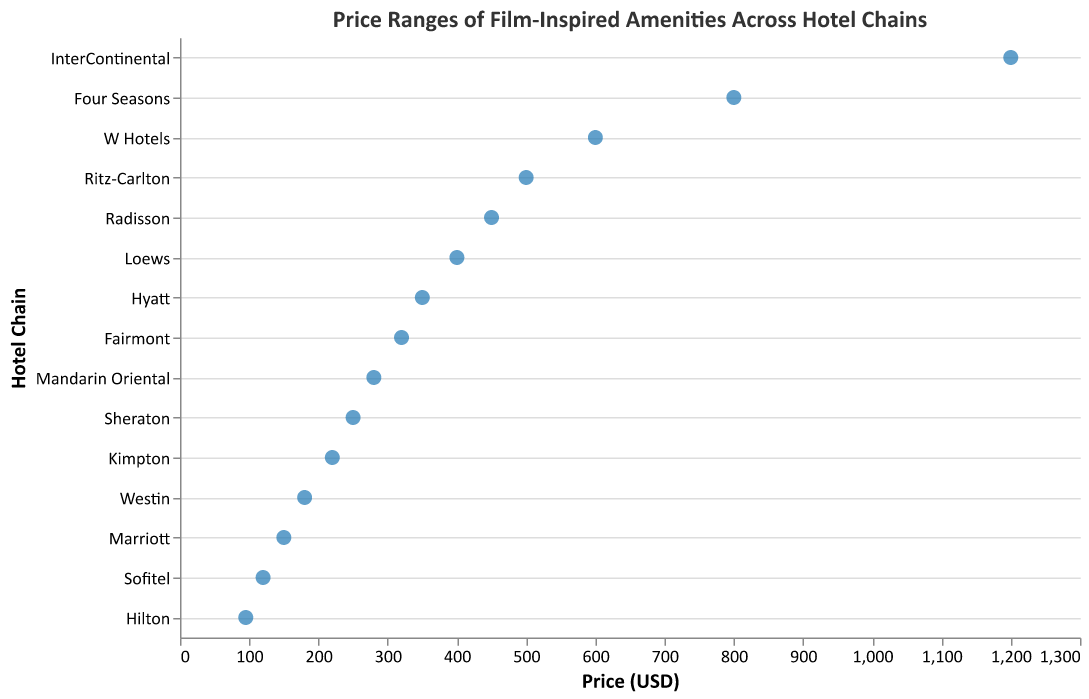How many hotel chains are represented in the plot? The plot shows a data point for each hotel chain. By counting the unique entries on the y-axis, we determine that there are 15 hotel chains represented.
Answer: 15 Which hotel chain features the most expensive film-inspired amenity? The most expensive amenity can be identified by locating the data point furthest to the right on the x-axis. It corresponds to InterContinental's "Game of Thrones Iron Throne Replica" priced at $1200.
Answer: InterContinental What is the price range of the amenities in the plot? The price range can be identified by noting the minimum and maximum x-axis values. The lowest price is for Hilton's "Star Wars Lightsaber Night Light" at $95, and the highest price is InterContinental's "Game of Thrones Iron Throne Replica" at $1200. The range is $1200 - $95 = $1105.
Answer: $1105 Which hotel chain has the lowest priced amenity? The lowest priced amenity can be found by identifying the data point closest to the left on the x-axis, which is Hilton's "Star Wars Lightsaber Night Light" priced at $95.
Answer: Hilton How many amenities are priced below $200? By scanning the x-axis for data points below the $200 mark, we can identify and count the corresponding points: Hilton, Marriott, Sofitel, and Westin provide such amenities. There are 4 in total.
Answer: 4 What is the average price of amenities offered by Ritz-Carlton and Radisson? To find the average price, add the prices of the amenities offered by Ritz-Carlton ($500) and Radisson ($450) and divide by the count of amenities (2). The calculation is ($500 + $450) / 2 = $475.
Answer: $475 Which amenity costs more, the "Jurassic Park Themed Pool" or the "Lord of the Rings Hobbit Hole Suite"? To compare, look at the x-axis values for these amenities. The "Jurassic Park Themed Pool" (Ritz-Carlton) costs $500, and the "Lord of the Rings Hobbit Hole Suite" (Four Seasons) costs $800. The latter costs more.
Answer: Lord of the Rings Hobbit Hole Suite What is the difference in price between Fairmont's and Loews' amenities? Locate the prices of Fairmont's "Ghostbusters Proton Pack Prop" ($320) and Loews' "Back to the Future DeLorean Mini-fridge" ($400). The difference is $400 - $320 = $80.
Answer: $80 Is there any hotel chain with an amenity priced exactly at $400? Look for a data point exactly at the $400 mark on the x-axis. Loews provides the "Back to the Future DeLorean Mini-fridge" at this price.
Answer: Yes How are the hotels sorted along the y-axis in the plot? The sorting on the y-axis is done according to the price of their amenities in descending order, starting with the highest price at the top.
Answer: By price (descending) 